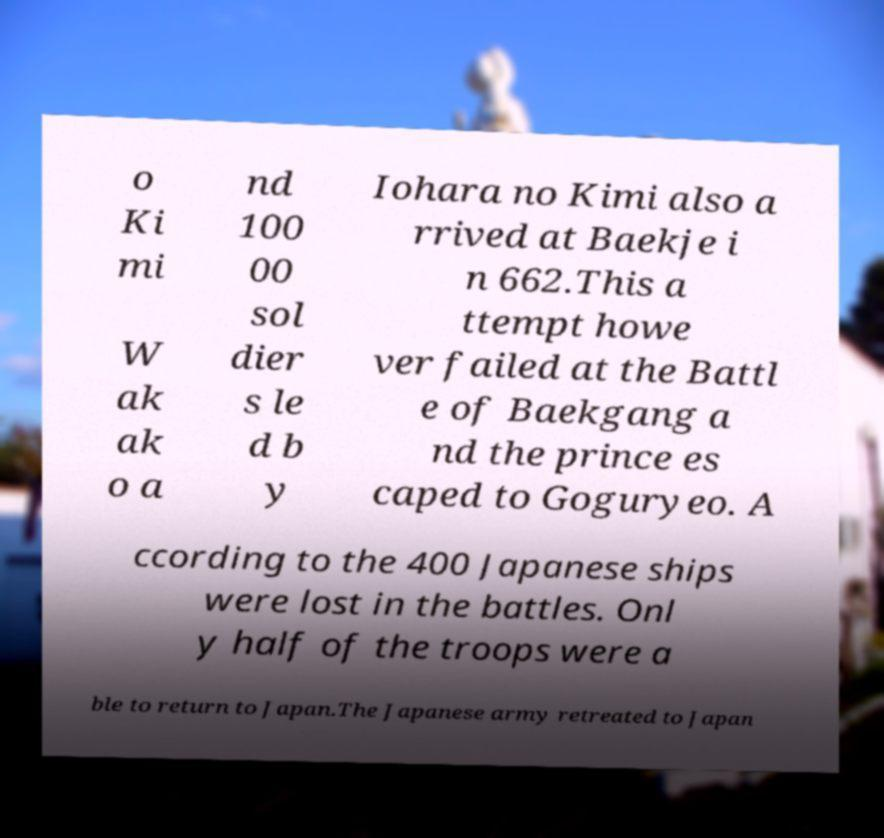For documentation purposes, I need the text within this image transcribed. Could you provide that? o Ki mi W ak ak o a nd 100 00 sol dier s le d b y Iohara no Kimi also a rrived at Baekje i n 662.This a ttempt howe ver failed at the Battl e of Baekgang a nd the prince es caped to Goguryeo. A ccording to the 400 Japanese ships were lost in the battles. Onl y half of the troops were a ble to return to Japan.The Japanese army retreated to Japan 